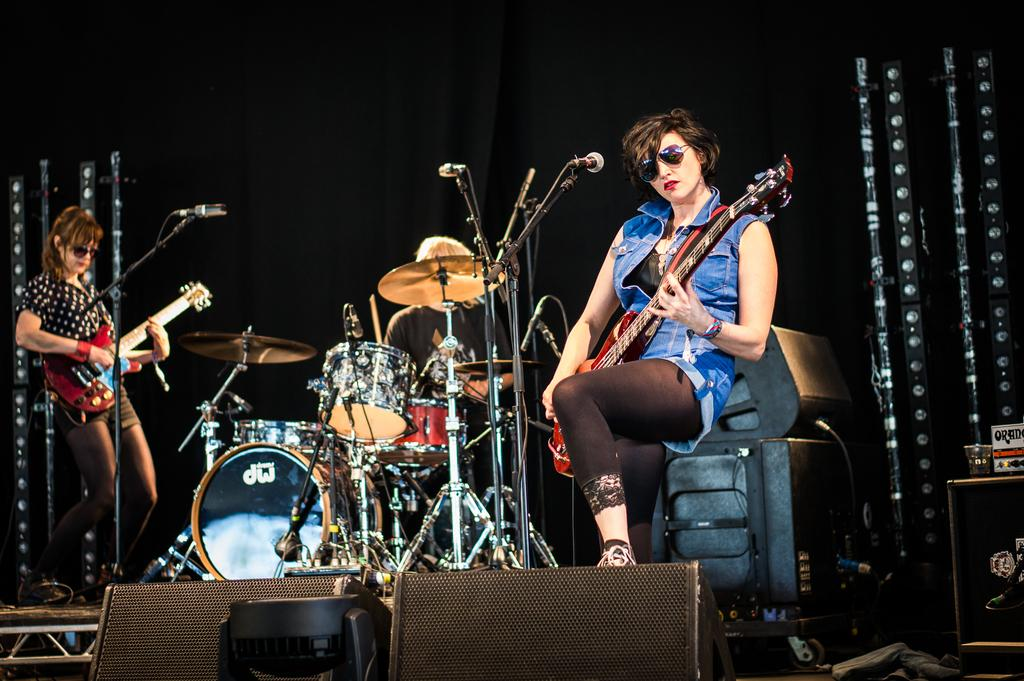What are the two persons in the image doing? The two persons in the image are sitting and playing musical instruments. What is the person standing holding in the image? The person standing is holding a guitar. What objects are present to amplify the sound of their instruments? Microphones with stands are visible in the image. What can be seen in the background of the image? There is a curtain in the background. What type of fear can be seen on the faces of the musicians in the image? There is no indication of fear on the faces of the musicians in the image; they appear to be focused on playing their instruments. What is the market like in the image? There is no market present in the image; it features musicians playing their instruments. 